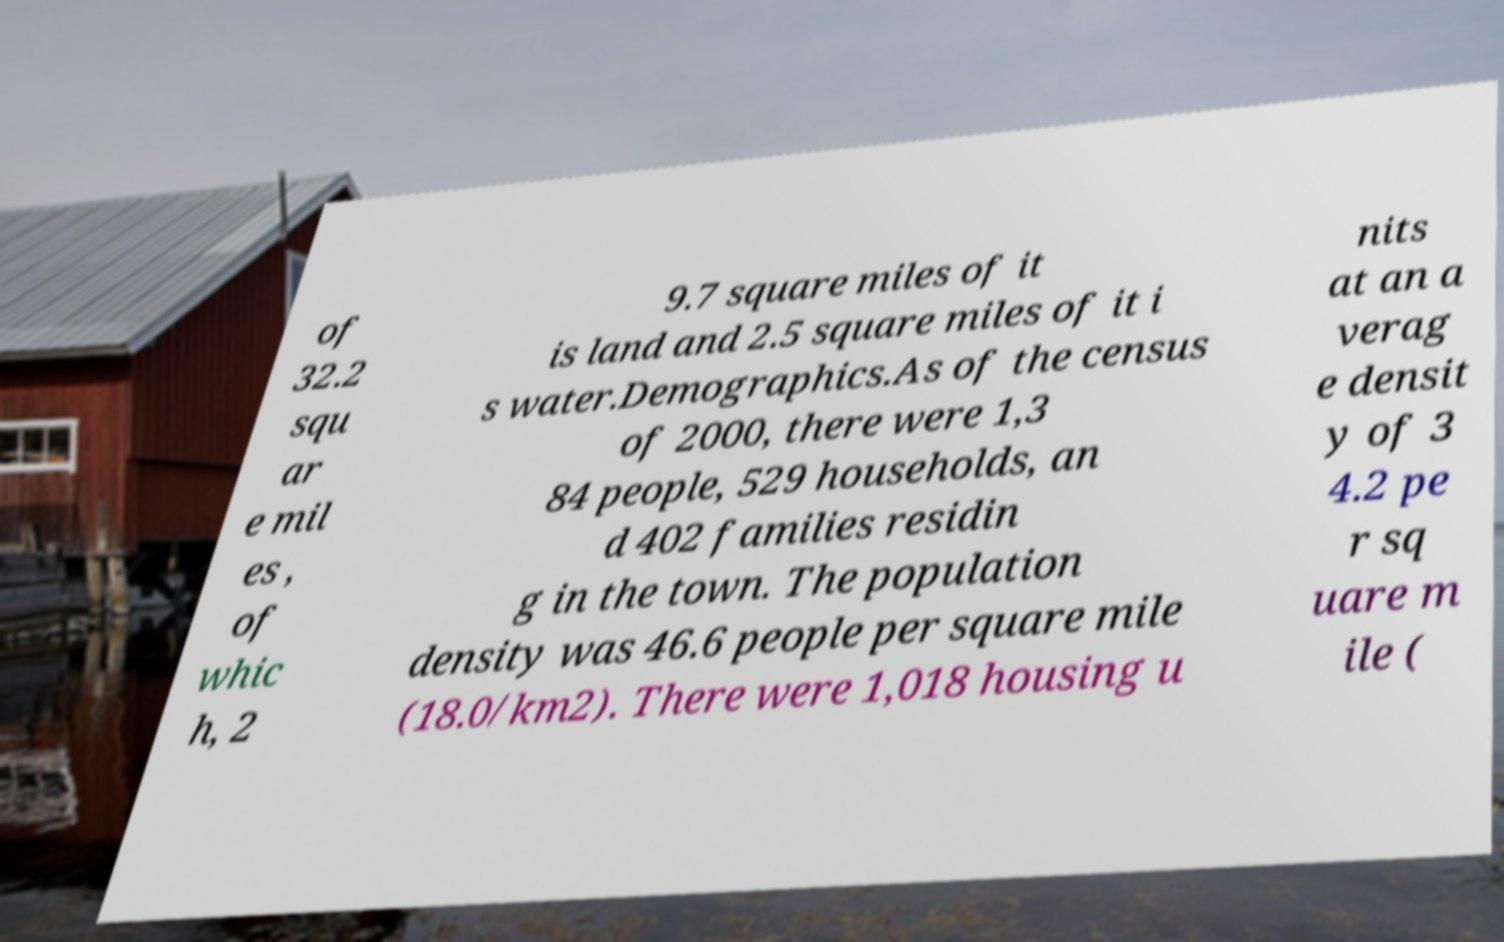What messages or text are displayed in this image? I need them in a readable, typed format. of 32.2 squ ar e mil es , of whic h, 2 9.7 square miles of it is land and 2.5 square miles of it i s water.Demographics.As of the census of 2000, there were 1,3 84 people, 529 households, an d 402 families residin g in the town. The population density was 46.6 people per square mile (18.0/km2). There were 1,018 housing u nits at an a verag e densit y of 3 4.2 pe r sq uare m ile ( 